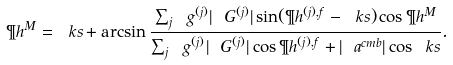Convert formula to latex. <formula><loc_0><loc_0><loc_500><loc_500>\P h ^ { M } = \ k s + \arcsin \frac { \sum _ { j } \ g ^ { ( j ) } | \ G ^ { ( j ) } | \sin ( { \P h ^ { ( j ) , f } - \ k s ) } \cos \P h ^ { M } } { \sum _ { j } \ g ^ { ( j ) } | \ G ^ { ( j ) } | \cos { \P h ^ { ( j ) , f } } + | \ a ^ { c m b } | \cos { \ k s } } .</formula> 